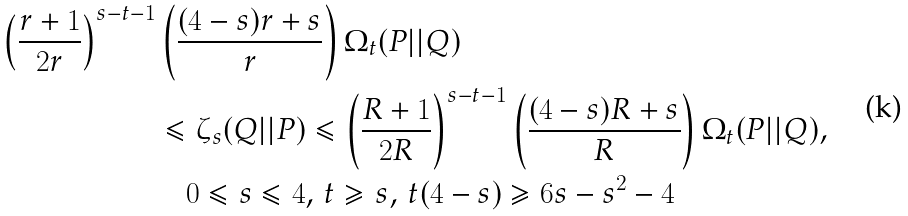<formula> <loc_0><loc_0><loc_500><loc_500>\left ( { \frac { r + 1 } { 2 r } } \right ) ^ { s - t - 1 } & \left ( { \frac { ( 4 - s ) r + s } { r } } \right ) \Omega _ { t } ( P | | Q ) \\ & \leqslant \zeta _ { s } ( Q | | P ) \leqslant \left ( { \frac { R + 1 } { 2 R } } \right ) ^ { s - t - 1 } \left ( { \frac { ( 4 - s ) R + s } { R } } \right ) \Omega _ { t } ( P | | Q ) , \\ & \quad 0 \leqslant s \leqslant 4 , \, t \geqslant s , \, t ( 4 - s ) \geqslant 6 s - s ^ { 2 } - 4</formula> 